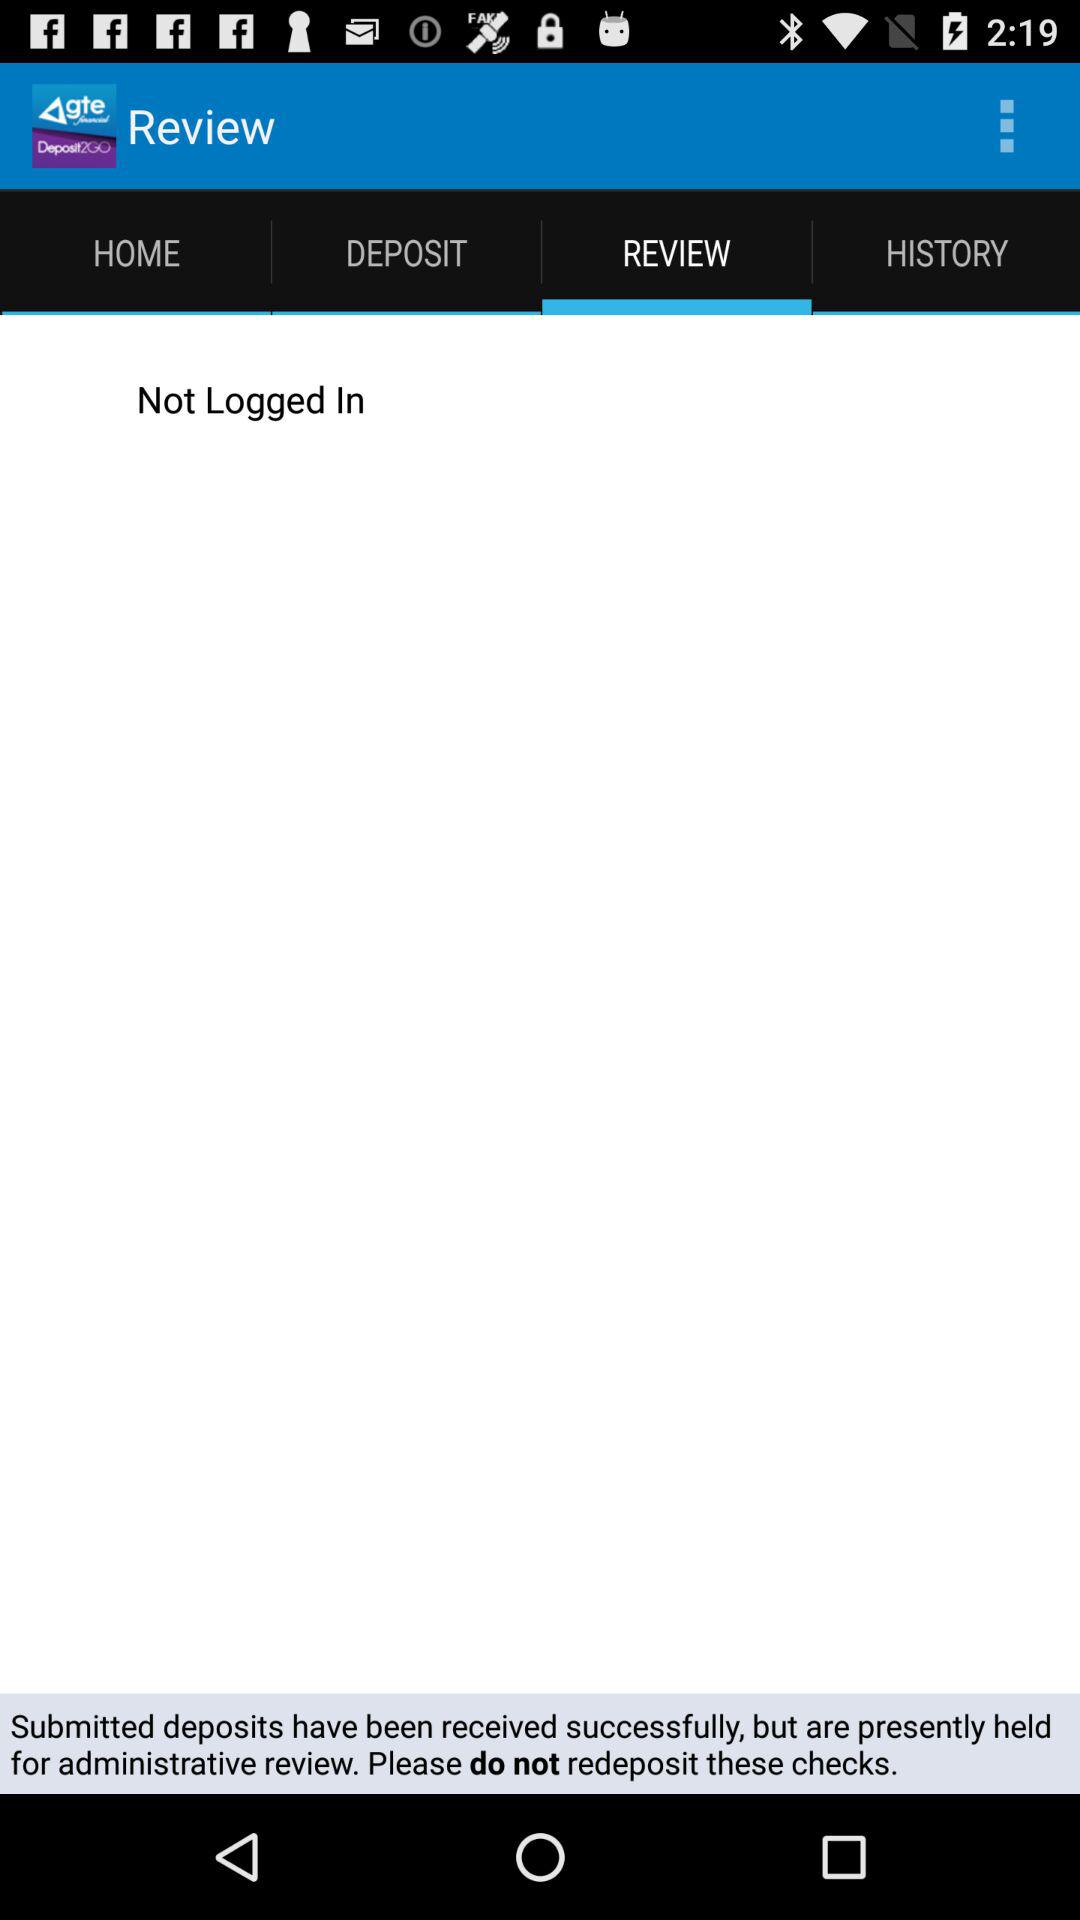Which tab is selected? The selected tab is "REVIEW". 